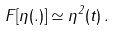<formula> <loc_0><loc_0><loc_500><loc_500>F [ \eta ( . ) ] \simeq \eta ^ { 2 } ( t ) \, .</formula> 